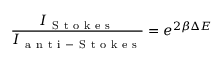Convert formula to latex. <formula><loc_0><loc_0><loc_500><loc_500>\frac { I _ { S t o k e s } } { I _ { a n t i - S t o k e s } } = e ^ { 2 \beta \Delta E }</formula> 